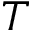<formula> <loc_0><loc_0><loc_500><loc_500>T</formula> 